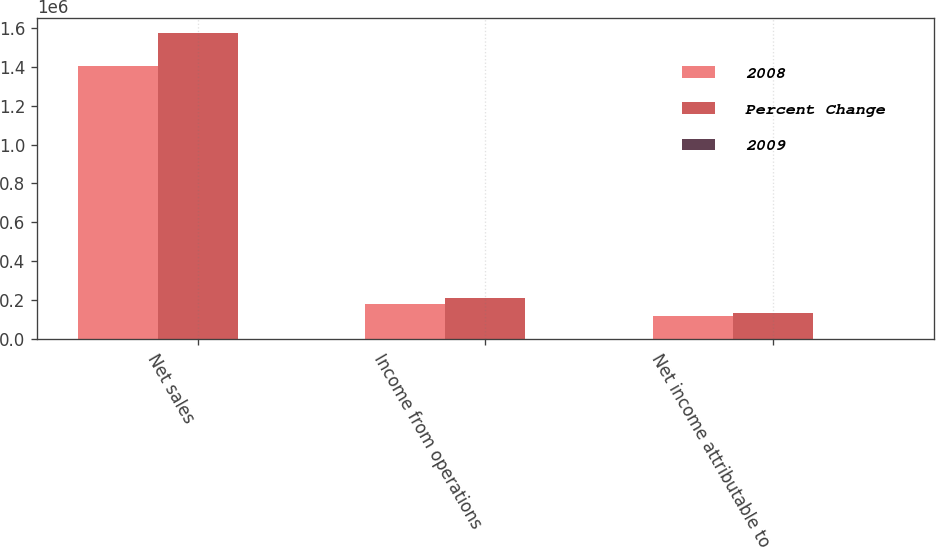Convert chart. <chart><loc_0><loc_0><loc_500><loc_500><stacked_bar_chart><ecel><fcel>Net sales<fcel>Income from operations<fcel>Net income attributable to<nl><fcel>2008<fcel>1.40162e+06<fcel>180032<fcel>115055<nl><fcel>Percent Change<fcel>1.57475e+06<fcel>212516<fcel>130551<nl><fcel>2009<fcel>11<fcel>15.3<fcel>11.9<nl></chart> 